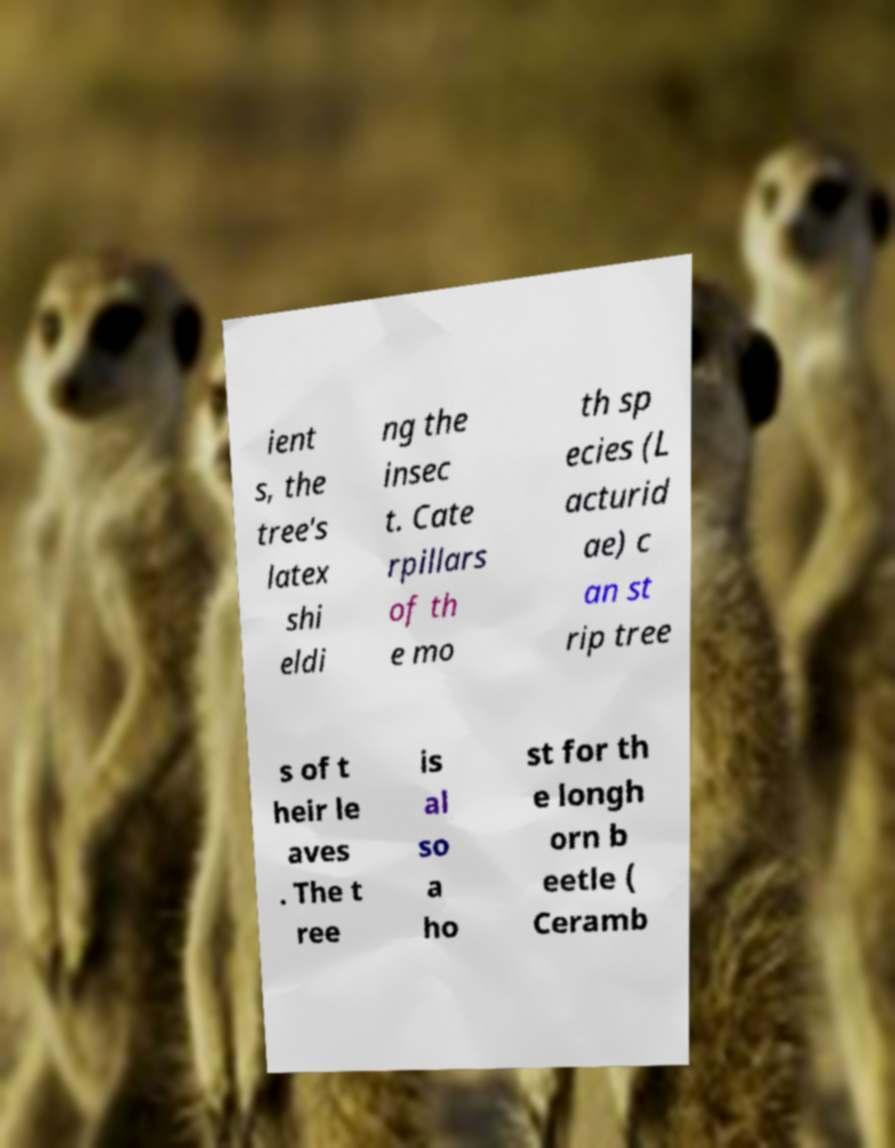Could you extract and type out the text from this image? ient s, the tree's latex shi eldi ng the insec t. Cate rpillars of th e mo th sp ecies (L acturid ae) c an st rip tree s of t heir le aves . The t ree is al so a ho st for th e longh orn b eetle ( Ceramb 